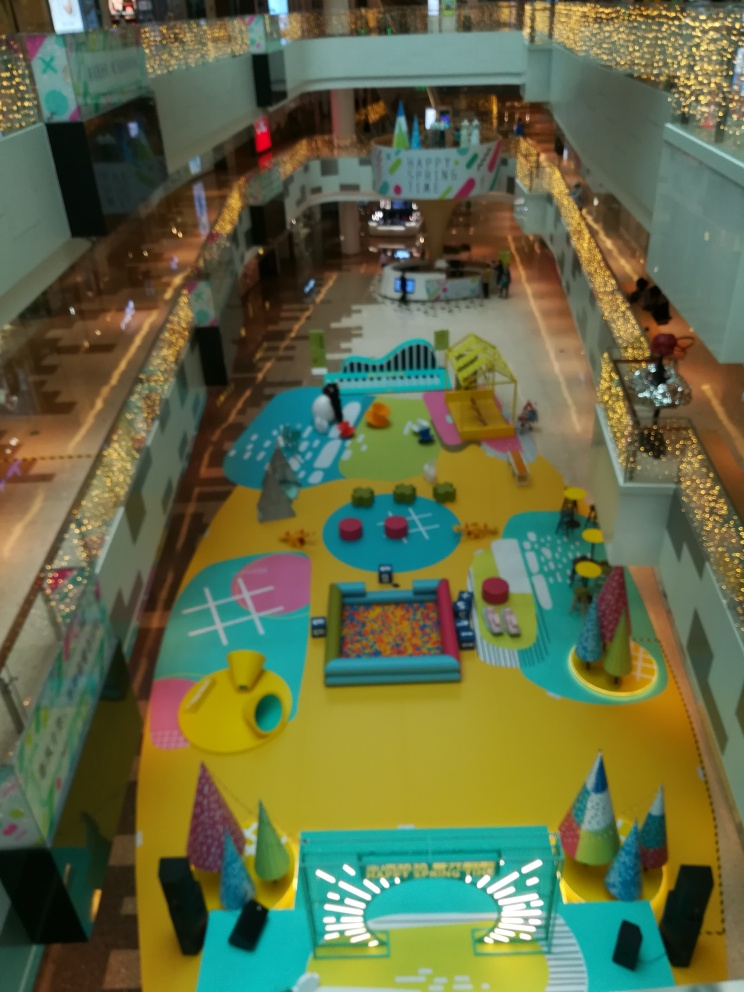What type of place is the subject of the photograph? A. City B. Amusement park C. Forest The photograph depicts an indoor area designed for play and recreation, which can be associated with an amusement area or family entertainment center located within a larger structure, such as a shopping mall. Decorated with vibrant colors, playful designs, and various activity stations, it is not an outdoor amusement park but rather an indoor play area for children. 